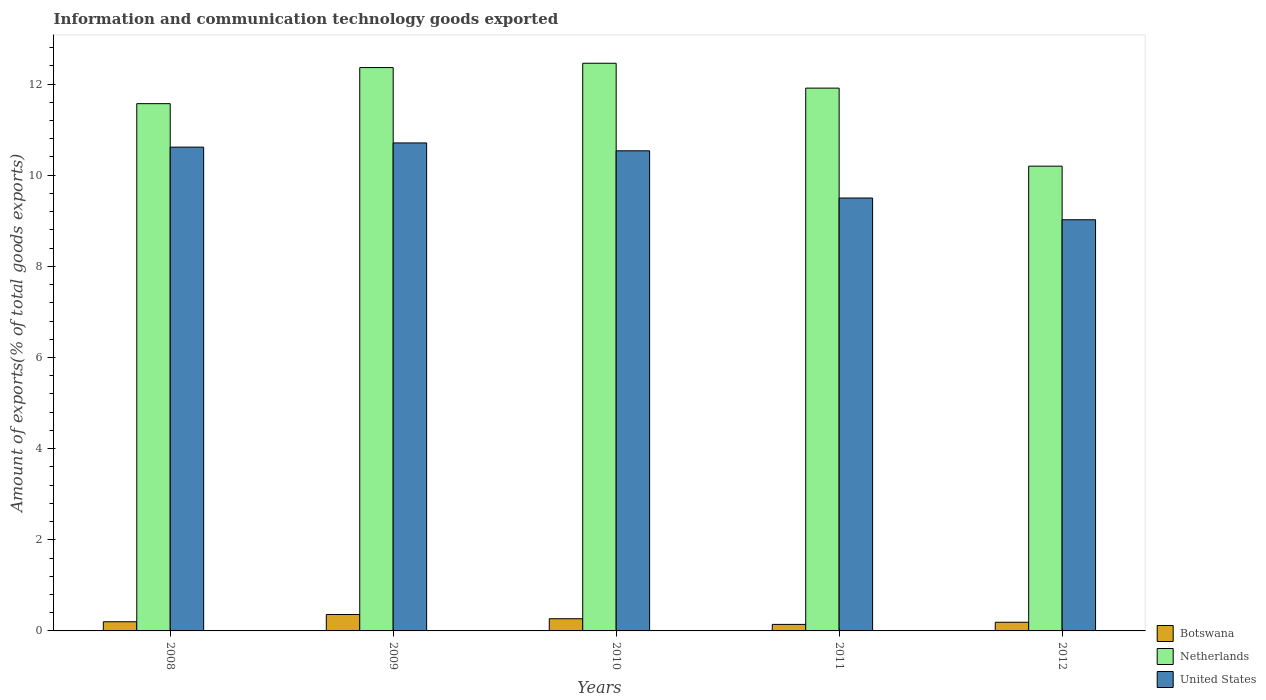Are the number of bars on each tick of the X-axis equal?
Provide a short and direct response. Yes. How many bars are there on the 2nd tick from the right?
Keep it short and to the point. 3. What is the label of the 2nd group of bars from the left?
Ensure brevity in your answer.  2009. What is the amount of goods exported in United States in 2009?
Offer a very short reply. 10.71. Across all years, what is the maximum amount of goods exported in United States?
Ensure brevity in your answer.  10.71. Across all years, what is the minimum amount of goods exported in United States?
Your answer should be compact. 9.02. In which year was the amount of goods exported in United States maximum?
Your answer should be compact. 2009. In which year was the amount of goods exported in Botswana minimum?
Your response must be concise. 2011. What is the total amount of goods exported in Netherlands in the graph?
Provide a short and direct response. 58.5. What is the difference between the amount of goods exported in Botswana in 2008 and that in 2009?
Your answer should be very brief. -0.16. What is the difference between the amount of goods exported in Botswana in 2011 and the amount of goods exported in United States in 2012?
Keep it short and to the point. -8.88. What is the average amount of goods exported in United States per year?
Give a very brief answer. 10.08. In the year 2008, what is the difference between the amount of goods exported in Netherlands and amount of goods exported in United States?
Give a very brief answer. 0.95. What is the ratio of the amount of goods exported in United States in 2011 to that in 2012?
Your answer should be very brief. 1.05. What is the difference between the highest and the second highest amount of goods exported in Netherlands?
Your response must be concise. 0.09. What is the difference between the highest and the lowest amount of goods exported in Netherlands?
Offer a terse response. 2.26. In how many years, is the amount of goods exported in United States greater than the average amount of goods exported in United States taken over all years?
Offer a very short reply. 3. Is the sum of the amount of goods exported in Netherlands in 2008 and 2009 greater than the maximum amount of goods exported in Botswana across all years?
Provide a succinct answer. Yes. What does the 1st bar from the left in 2008 represents?
Keep it short and to the point. Botswana. What does the 1st bar from the right in 2008 represents?
Keep it short and to the point. United States. How many years are there in the graph?
Your response must be concise. 5. What is the difference between two consecutive major ticks on the Y-axis?
Keep it short and to the point. 2. Where does the legend appear in the graph?
Offer a terse response. Bottom right. How are the legend labels stacked?
Provide a succinct answer. Vertical. What is the title of the graph?
Make the answer very short. Information and communication technology goods exported. Does "High income" appear as one of the legend labels in the graph?
Give a very brief answer. No. What is the label or title of the X-axis?
Your response must be concise. Years. What is the label or title of the Y-axis?
Provide a succinct answer. Amount of exports(% of total goods exports). What is the Amount of exports(% of total goods exports) of Botswana in 2008?
Your answer should be very brief. 0.2. What is the Amount of exports(% of total goods exports) of Netherlands in 2008?
Give a very brief answer. 11.57. What is the Amount of exports(% of total goods exports) of United States in 2008?
Your response must be concise. 10.62. What is the Amount of exports(% of total goods exports) of Botswana in 2009?
Ensure brevity in your answer.  0.36. What is the Amount of exports(% of total goods exports) in Netherlands in 2009?
Provide a succinct answer. 12.36. What is the Amount of exports(% of total goods exports) of United States in 2009?
Your answer should be very brief. 10.71. What is the Amount of exports(% of total goods exports) in Botswana in 2010?
Offer a terse response. 0.27. What is the Amount of exports(% of total goods exports) of Netherlands in 2010?
Offer a terse response. 12.46. What is the Amount of exports(% of total goods exports) of United States in 2010?
Ensure brevity in your answer.  10.54. What is the Amount of exports(% of total goods exports) in Botswana in 2011?
Ensure brevity in your answer.  0.14. What is the Amount of exports(% of total goods exports) of Netherlands in 2011?
Make the answer very short. 11.91. What is the Amount of exports(% of total goods exports) in United States in 2011?
Your response must be concise. 9.5. What is the Amount of exports(% of total goods exports) of Botswana in 2012?
Provide a short and direct response. 0.19. What is the Amount of exports(% of total goods exports) in Netherlands in 2012?
Give a very brief answer. 10.2. What is the Amount of exports(% of total goods exports) in United States in 2012?
Your answer should be very brief. 9.02. Across all years, what is the maximum Amount of exports(% of total goods exports) in Botswana?
Offer a terse response. 0.36. Across all years, what is the maximum Amount of exports(% of total goods exports) of Netherlands?
Offer a terse response. 12.46. Across all years, what is the maximum Amount of exports(% of total goods exports) of United States?
Offer a very short reply. 10.71. Across all years, what is the minimum Amount of exports(% of total goods exports) of Botswana?
Your answer should be compact. 0.14. Across all years, what is the minimum Amount of exports(% of total goods exports) of Netherlands?
Keep it short and to the point. 10.2. Across all years, what is the minimum Amount of exports(% of total goods exports) in United States?
Your answer should be very brief. 9.02. What is the total Amount of exports(% of total goods exports) in Botswana in the graph?
Provide a short and direct response. 1.16. What is the total Amount of exports(% of total goods exports) in Netherlands in the graph?
Provide a succinct answer. 58.5. What is the total Amount of exports(% of total goods exports) in United States in the graph?
Provide a short and direct response. 50.38. What is the difference between the Amount of exports(% of total goods exports) of Botswana in 2008 and that in 2009?
Make the answer very short. -0.16. What is the difference between the Amount of exports(% of total goods exports) in Netherlands in 2008 and that in 2009?
Offer a very short reply. -0.79. What is the difference between the Amount of exports(% of total goods exports) in United States in 2008 and that in 2009?
Keep it short and to the point. -0.09. What is the difference between the Amount of exports(% of total goods exports) in Botswana in 2008 and that in 2010?
Provide a succinct answer. -0.07. What is the difference between the Amount of exports(% of total goods exports) of Netherlands in 2008 and that in 2010?
Offer a terse response. -0.89. What is the difference between the Amount of exports(% of total goods exports) of United States in 2008 and that in 2010?
Your response must be concise. 0.08. What is the difference between the Amount of exports(% of total goods exports) in Botswana in 2008 and that in 2011?
Your answer should be compact. 0.06. What is the difference between the Amount of exports(% of total goods exports) of Netherlands in 2008 and that in 2011?
Your response must be concise. -0.34. What is the difference between the Amount of exports(% of total goods exports) of United States in 2008 and that in 2011?
Offer a very short reply. 1.12. What is the difference between the Amount of exports(% of total goods exports) of Botswana in 2008 and that in 2012?
Your response must be concise. 0.01. What is the difference between the Amount of exports(% of total goods exports) in Netherlands in 2008 and that in 2012?
Offer a very short reply. 1.37. What is the difference between the Amount of exports(% of total goods exports) of United States in 2008 and that in 2012?
Make the answer very short. 1.59. What is the difference between the Amount of exports(% of total goods exports) in Botswana in 2009 and that in 2010?
Keep it short and to the point. 0.09. What is the difference between the Amount of exports(% of total goods exports) in Netherlands in 2009 and that in 2010?
Make the answer very short. -0.09. What is the difference between the Amount of exports(% of total goods exports) of United States in 2009 and that in 2010?
Keep it short and to the point. 0.17. What is the difference between the Amount of exports(% of total goods exports) in Botswana in 2009 and that in 2011?
Your answer should be compact. 0.22. What is the difference between the Amount of exports(% of total goods exports) of Netherlands in 2009 and that in 2011?
Your response must be concise. 0.45. What is the difference between the Amount of exports(% of total goods exports) in United States in 2009 and that in 2011?
Provide a succinct answer. 1.21. What is the difference between the Amount of exports(% of total goods exports) of Botswana in 2009 and that in 2012?
Keep it short and to the point. 0.17. What is the difference between the Amount of exports(% of total goods exports) of Netherlands in 2009 and that in 2012?
Keep it short and to the point. 2.16. What is the difference between the Amount of exports(% of total goods exports) in United States in 2009 and that in 2012?
Ensure brevity in your answer.  1.69. What is the difference between the Amount of exports(% of total goods exports) of Botswana in 2010 and that in 2011?
Your answer should be compact. 0.12. What is the difference between the Amount of exports(% of total goods exports) of Netherlands in 2010 and that in 2011?
Make the answer very short. 0.55. What is the difference between the Amount of exports(% of total goods exports) of United States in 2010 and that in 2011?
Provide a short and direct response. 1.04. What is the difference between the Amount of exports(% of total goods exports) in Botswana in 2010 and that in 2012?
Offer a very short reply. 0.08. What is the difference between the Amount of exports(% of total goods exports) of Netherlands in 2010 and that in 2012?
Offer a terse response. 2.26. What is the difference between the Amount of exports(% of total goods exports) in United States in 2010 and that in 2012?
Give a very brief answer. 1.51. What is the difference between the Amount of exports(% of total goods exports) of Botswana in 2011 and that in 2012?
Give a very brief answer. -0.05. What is the difference between the Amount of exports(% of total goods exports) of Netherlands in 2011 and that in 2012?
Offer a very short reply. 1.71. What is the difference between the Amount of exports(% of total goods exports) of United States in 2011 and that in 2012?
Ensure brevity in your answer.  0.48. What is the difference between the Amount of exports(% of total goods exports) in Botswana in 2008 and the Amount of exports(% of total goods exports) in Netherlands in 2009?
Your answer should be compact. -12.16. What is the difference between the Amount of exports(% of total goods exports) in Botswana in 2008 and the Amount of exports(% of total goods exports) in United States in 2009?
Provide a short and direct response. -10.51. What is the difference between the Amount of exports(% of total goods exports) of Netherlands in 2008 and the Amount of exports(% of total goods exports) of United States in 2009?
Offer a very short reply. 0.86. What is the difference between the Amount of exports(% of total goods exports) of Botswana in 2008 and the Amount of exports(% of total goods exports) of Netherlands in 2010?
Your response must be concise. -12.26. What is the difference between the Amount of exports(% of total goods exports) in Botswana in 2008 and the Amount of exports(% of total goods exports) in United States in 2010?
Give a very brief answer. -10.33. What is the difference between the Amount of exports(% of total goods exports) of Netherlands in 2008 and the Amount of exports(% of total goods exports) of United States in 2010?
Your answer should be very brief. 1.03. What is the difference between the Amount of exports(% of total goods exports) in Botswana in 2008 and the Amount of exports(% of total goods exports) in Netherlands in 2011?
Your answer should be compact. -11.71. What is the difference between the Amount of exports(% of total goods exports) in Botswana in 2008 and the Amount of exports(% of total goods exports) in United States in 2011?
Provide a short and direct response. -9.3. What is the difference between the Amount of exports(% of total goods exports) in Netherlands in 2008 and the Amount of exports(% of total goods exports) in United States in 2011?
Your answer should be compact. 2.07. What is the difference between the Amount of exports(% of total goods exports) of Botswana in 2008 and the Amount of exports(% of total goods exports) of Netherlands in 2012?
Provide a short and direct response. -10. What is the difference between the Amount of exports(% of total goods exports) in Botswana in 2008 and the Amount of exports(% of total goods exports) in United States in 2012?
Your answer should be compact. -8.82. What is the difference between the Amount of exports(% of total goods exports) of Netherlands in 2008 and the Amount of exports(% of total goods exports) of United States in 2012?
Provide a succinct answer. 2.55. What is the difference between the Amount of exports(% of total goods exports) in Botswana in 2009 and the Amount of exports(% of total goods exports) in Netherlands in 2010?
Ensure brevity in your answer.  -12.1. What is the difference between the Amount of exports(% of total goods exports) in Botswana in 2009 and the Amount of exports(% of total goods exports) in United States in 2010?
Your answer should be very brief. -10.17. What is the difference between the Amount of exports(% of total goods exports) in Netherlands in 2009 and the Amount of exports(% of total goods exports) in United States in 2010?
Offer a terse response. 1.83. What is the difference between the Amount of exports(% of total goods exports) in Botswana in 2009 and the Amount of exports(% of total goods exports) in Netherlands in 2011?
Offer a very short reply. -11.55. What is the difference between the Amount of exports(% of total goods exports) of Botswana in 2009 and the Amount of exports(% of total goods exports) of United States in 2011?
Give a very brief answer. -9.14. What is the difference between the Amount of exports(% of total goods exports) in Netherlands in 2009 and the Amount of exports(% of total goods exports) in United States in 2011?
Your answer should be very brief. 2.86. What is the difference between the Amount of exports(% of total goods exports) in Botswana in 2009 and the Amount of exports(% of total goods exports) in Netherlands in 2012?
Offer a very short reply. -9.84. What is the difference between the Amount of exports(% of total goods exports) in Botswana in 2009 and the Amount of exports(% of total goods exports) in United States in 2012?
Your answer should be compact. -8.66. What is the difference between the Amount of exports(% of total goods exports) in Netherlands in 2009 and the Amount of exports(% of total goods exports) in United States in 2012?
Make the answer very short. 3.34. What is the difference between the Amount of exports(% of total goods exports) in Botswana in 2010 and the Amount of exports(% of total goods exports) in Netherlands in 2011?
Your answer should be very brief. -11.64. What is the difference between the Amount of exports(% of total goods exports) of Botswana in 2010 and the Amount of exports(% of total goods exports) of United States in 2011?
Offer a very short reply. -9.23. What is the difference between the Amount of exports(% of total goods exports) of Netherlands in 2010 and the Amount of exports(% of total goods exports) of United States in 2011?
Provide a short and direct response. 2.96. What is the difference between the Amount of exports(% of total goods exports) in Botswana in 2010 and the Amount of exports(% of total goods exports) in Netherlands in 2012?
Give a very brief answer. -9.93. What is the difference between the Amount of exports(% of total goods exports) in Botswana in 2010 and the Amount of exports(% of total goods exports) in United States in 2012?
Keep it short and to the point. -8.76. What is the difference between the Amount of exports(% of total goods exports) in Netherlands in 2010 and the Amount of exports(% of total goods exports) in United States in 2012?
Your response must be concise. 3.43. What is the difference between the Amount of exports(% of total goods exports) of Botswana in 2011 and the Amount of exports(% of total goods exports) of Netherlands in 2012?
Offer a terse response. -10.06. What is the difference between the Amount of exports(% of total goods exports) of Botswana in 2011 and the Amount of exports(% of total goods exports) of United States in 2012?
Make the answer very short. -8.88. What is the difference between the Amount of exports(% of total goods exports) in Netherlands in 2011 and the Amount of exports(% of total goods exports) in United States in 2012?
Your answer should be compact. 2.89. What is the average Amount of exports(% of total goods exports) in Botswana per year?
Offer a very short reply. 0.23. What is the average Amount of exports(% of total goods exports) in Netherlands per year?
Offer a very short reply. 11.7. What is the average Amount of exports(% of total goods exports) of United States per year?
Your response must be concise. 10.08. In the year 2008, what is the difference between the Amount of exports(% of total goods exports) of Botswana and Amount of exports(% of total goods exports) of Netherlands?
Offer a very short reply. -11.37. In the year 2008, what is the difference between the Amount of exports(% of total goods exports) in Botswana and Amount of exports(% of total goods exports) in United States?
Give a very brief answer. -10.42. In the year 2008, what is the difference between the Amount of exports(% of total goods exports) of Netherlands and Amount of exports(% of total goods exports) of United States?
Ensure brevity in your answer.  0.95. In the year 2009, what is the difference between the Amount of exports(% of total goods exports) in Botswana and Amount of exports(% of total goods exports) in Netherlands?
Your answer should be very brief. -12. In the year 2009, what is the difference between the Amount of exports(% of total goods exports) in Botswana and Amount of exports(% of total goods exports) in United States?
Your answer should be compact. -10.35. In the year 2009, what is the difference between the Amount of exports(% of total goods exports) in Netherlands and Amount of exports(% of total goods exports) in United States?
Offer a terse response. 1.65. In the year 2010, what is the difference between the Amount of exports(% of total goods exports) in Botswana and Amount of exports(% of total goods exports) in Netherlands?
Ensure brevity in your answer.  -12.19. In the year 2010, what is the difference between the Amount of exports(% of total goods exports) in Botswana and Amount of exports(% of total goods exports) in United States?
Your answer should be compact. -10.27. In the year 2010, what is the difference between the Amount of exports(% of total goods exports) in Netherlands and Amount of exports(% of total goods exports) in United States?
Provide a succinct answer. 1.92. In the year 2011, what is the difference between the Amount of exports(% of total goods exports) of Botswana and Amount of exports(% of total goods exports) of Netherlands?
Your answer should be compact. -11.77. In the year 2011, what is the difference between the Amount of exports(% of total goods exports) in Botswana and Amount of exports(% of total goods exports) in United States?
Ensure brevity in your answer.  -9.36. In the year 2011, what is the difference between the Amount of exports(% of total goods exports) in Netherlands and Amount of exports(% of total goods exports) in United States?
Ensure brevity in your answer.  2.41. In the year 2012, what is the difference between the Amount of exports(% of total goods exports) in Botswana and Amount of exports(% of total goods exports) in Netherlands?
Give a very brief answer. -10.01. In the year 2012, what is the difference between the Amount of exports(% of total goods exports) in Botswana and Amount of exports(% of total goods exports) in United States?
Keep it short and to the point. -8.83. In the year 2012, what is the difference between the Amount of exports(% of total goods exports) of Netherlands and Amount of exports(% of total goods exports) of United States?
Ensure brevity in your answer.  1.18. What is the ratio of the Amount of exports(% of total goods exports) in Botswana in 2008 to that in 2009?
Provide a short and direct response. 0.56. What is the ratio of the Amount of exports(% of total goods exports) in Netherlands in 2008 to that in 2009?
Give a very brief answer. 0.94. What is the ratio of the Amount of exports(% of total goods exports) in Botswana in 2008 to that in 2010?
Your response must be concise. 0.75. What is the ratio of the Amount of exports(% of total goods exports) of Netherlands in 2008 to that in 2010?
Provide a succinct answer. 0.93. What is the ratio of the Amount of exports(% of total goods exports) in United States in 2008 to that in 2010?
Your answer should be very brief. 1.01. What is the ratio of the Amount of exports(% of total goods exports) of Botswana in 2008 to that in 2011?
Offer a very short reply. 1.4. What is the ratio of the Amount of exports(% of total goods exports) in Netherlands in 2008 to that in 2011?
Your answer should be compact. 0.97. What is the ratio of the Amount of exports(% of total goods exports) in United States in 2008 to that in 2011?
Your answer should be compact. 1.12. What is the ratio of the Amount of exports(% of total goods exports) in Botswana in 2008 to that in 2012?
Ensure brevity in your answer.  1.05. What is the ratio of the Amount of exports(% of total goods exports) in Netherlands in 2008 to that in 2012?
Your response must be concise. 1.13. What is the ratio of the Amount of exports(% of total goods exports) of United States in 2008 to that in 2012?
Offer a very short reply. 1.18. What is the ratio of the Amount of exports(% of total goods exports) of Botswana in 2009 to that in 2010?
Give a very brief answer. 1.35. What is the ratio of the Amount of exports(% of total goods exports) of Netherlands in 2009 to that in 2010?
Provide a succinct answer. 0.99. What is the ratio of the Amount of exports(% of total goods exports) in United States in 2009 to that in 2010?
Provide a short and direct response. 1.02. What is the ratio of the Amount of exports(% of total goods exports) of Botswana in 2009 to that in 2011?
Your answer should be compact. 2.52. What is the ratio of the Amount of exports(% of total goods exports) in Netherlands in 2009 to that in 2011?
Offer a very short reply. 1.04. What is the ratio of the Amount of exports(% of total goods exports) of United States in 2009 to that in 2011?
Your answer should be compact. 1.13. What is the ratio of the Amount of exports(% of total goods exports) of Botswana in 2009 to that in 2012?
Offer a terse response. 1.89. What is the ratio of the Amount of exports(% of total goods exports) of Netherlands in 2009 to that in 2012?
Provide a short and direct response. 1.21. What is the ratio of the Amount of exports(% of total goods exports) of United States in 2009 to that in 2012?
Your response must be concise. 1.19. What is the ratio of the Amount of exports(% of total goods exports) of Botswana in 2010 to that in 2011?
Ensure brevity in your answer.  1.87. What is the ratio of the Amount of exports(% of total goods exports) in Netherlands in 2010 to that in 2011?
Provide a succinct answer. 1.05. What is the ratio of the Amount of exports(% of total goods exports) of United States in 2010 to that in 2011?
Keep it short and to the point. 1.11. What is the ratio of the Amount of exports(% of total goods exports) of Botswana in 2010 to that in 2012?
Ensure brevity in your answer.  1.4. What is the ratio of the Amount of exports(% of total goods exports) in Netherlands in 2010 to that in 2012?
Your answer should be very brief. 1.22. What is the ratio of the Amount of exports(% of total goods exports) in United States in 2010 to that in 2012?
Offer a terse response. 1.17. What is the ratio of the Amount of exports(% of total goods exports) of Botswana in 2011 to that in 2012?
Give a very brief answer. 0.75. What is the ratio of the Amount of exports(% of total goods exports) of Netherlands in 2011 to that in 2012?
Make the answer very short. 1.17. What is the ratio of the Amount of exports(% of total goods exports) in United States in 2011 to that in 2012?
Give a very brief answer. 1.05. What is the difference between the highest and the second highest Amount of exports(% of total goods exports) in Botswana?
Make the answer very short. 0.09. What is the difference between the highest and the second highest Amount of exports(% of total goods exports) of Netherlands?
Keep it short and to the point. 0.09. What is the difference between the highest and the second highest Amount of exports(% of total goods exports) of United States?
Your answer should be compact. 0.09. What is the difference between the highest and the lowest Amount of exports(% of total goods exports) of Botswana?
Offer a very short reply. 0.22. What is the difference between the highest and the lowest Amount of exports(% of total goods exports) in Netherlands?
Provide a succinct answer. 2.26. What is the difference between the highest and the lowest Amount of exports(% of total goods exports) in United States?
Your response must be concise. 1.69. 